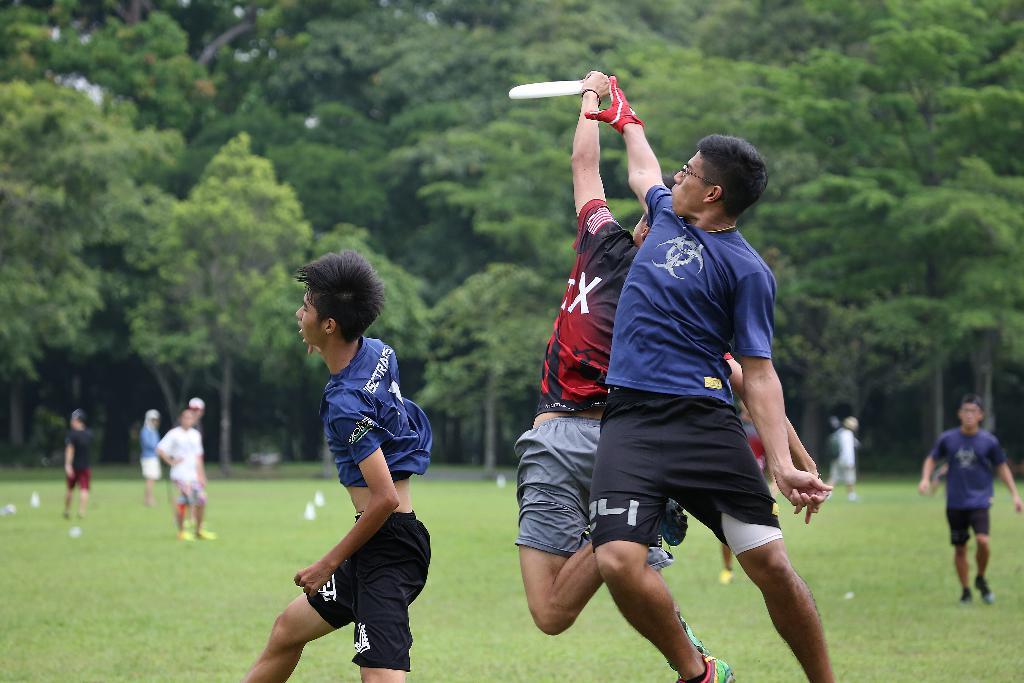What letter is shown red shirt?
Your response must be concise. X. What number is on the shorts of the player in blue who is jumping?
Your response must be concise. 24. 